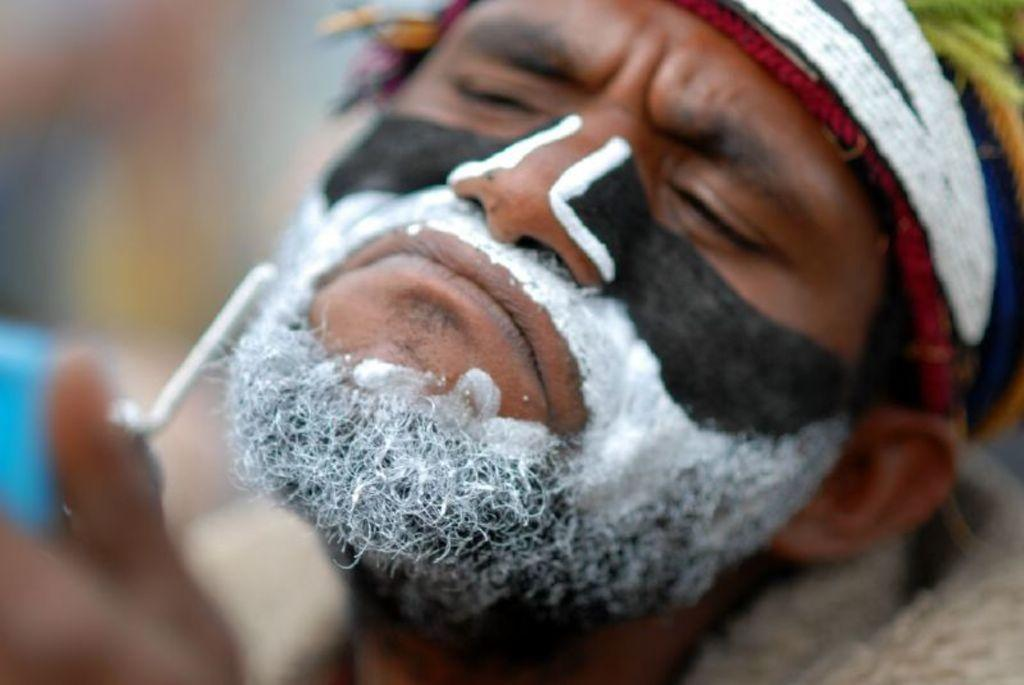What is the main subject of the image? There is a man in the image. Can you describe the man's appearance? The man has a black and white color painting on him. What can be seen in the background of the image? There is a blurred image in the image in the background of the image. How many wings does the man have in the image? The man does not have any wings in the image. What type of sorting method is being used by the man in the image? There is no sorting method being used by the man in the image. 